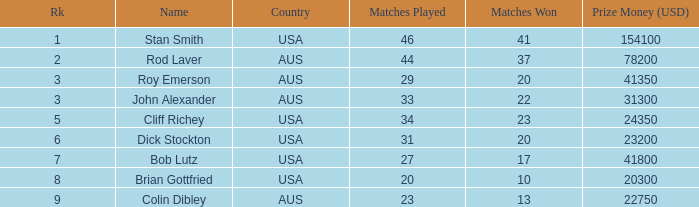How much prize money (in usd) did bob lutz win 41800.0. 